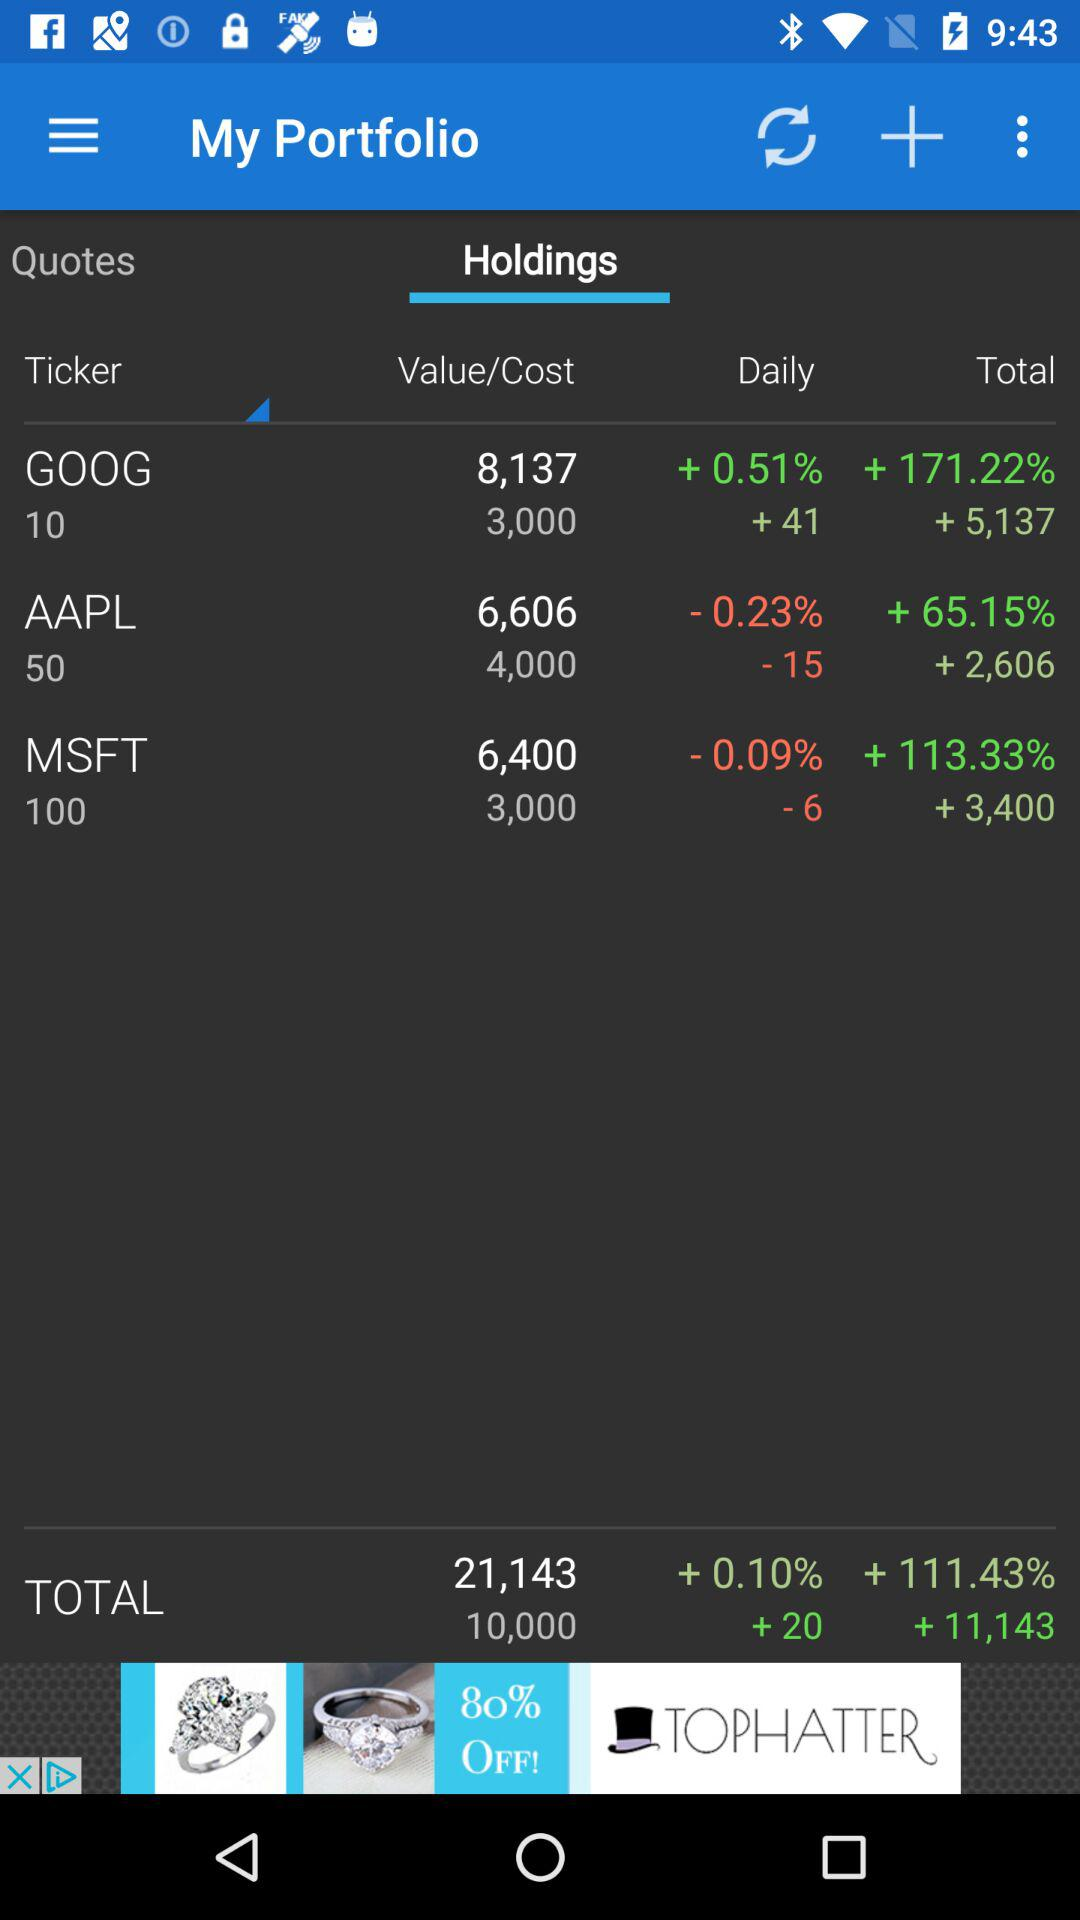What is the total cost of stock holdings? The total cost is 21,143. 